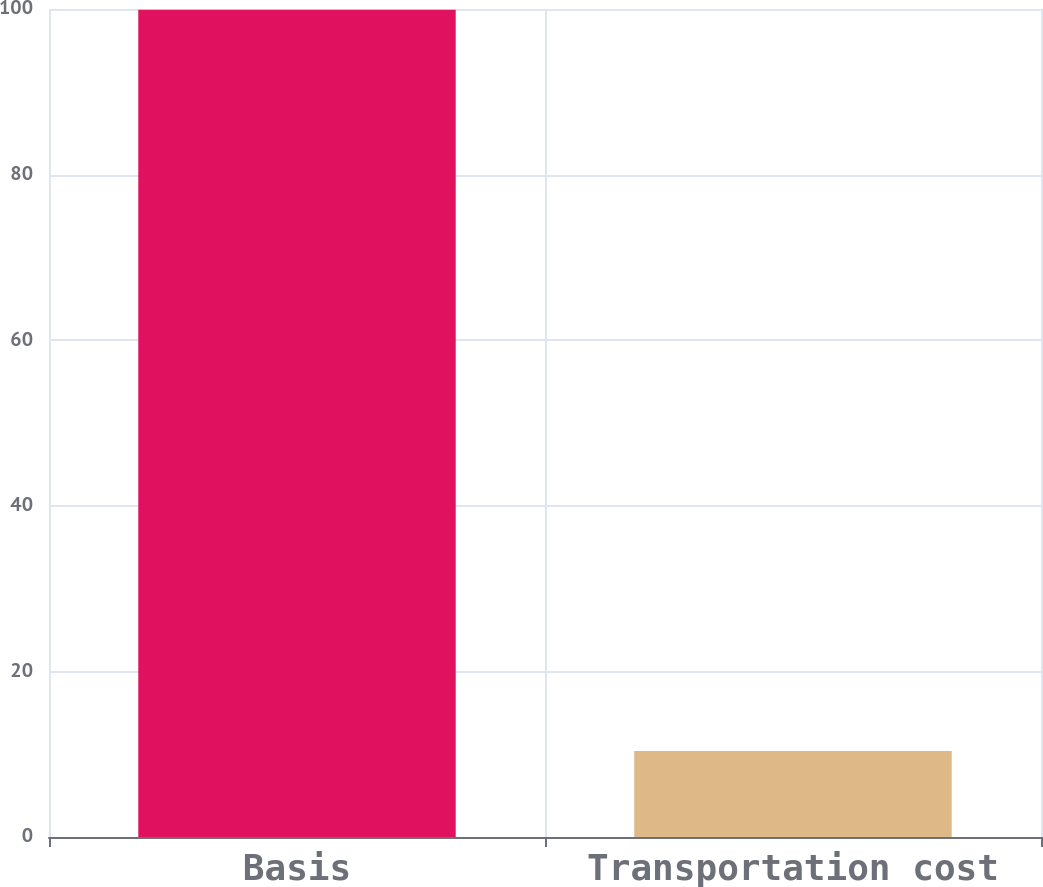<chart> <loc_0><loc_0><loc_500><loc_500><bar_chart><fcel>Basis<fcel>Transportation cost<nl><fcel>99.9<fcel>10.4<nl></chart> 